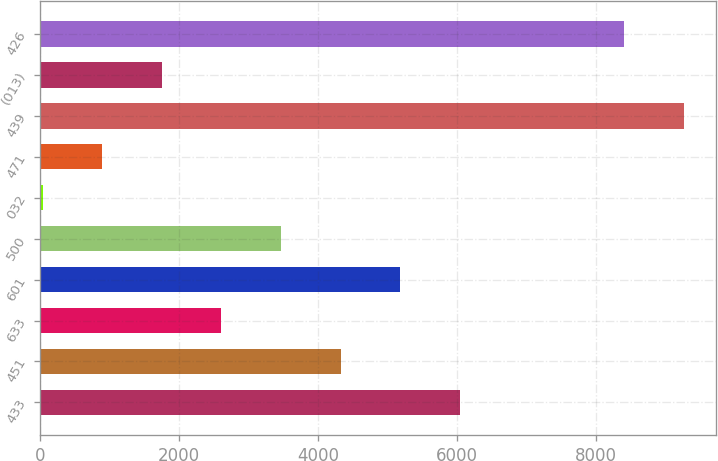<chart> <loc_0><loc_0><loc_500><loc_500><bar_chart><fcel>433<fcel>451<fcel>633<fcel>601<fcel>500<fcel>032<fcel>471<fcel>439<fcel>(013)<fcel>426<nl><fcel>6042.7<fcel>4326.5<fcel>2610.3<fcel>5184.6<fcel>3468.4<fcel>36<fcel>894.1<fcel>9267.1<fcel>1752.2<fcel>8409<nl></chart> 